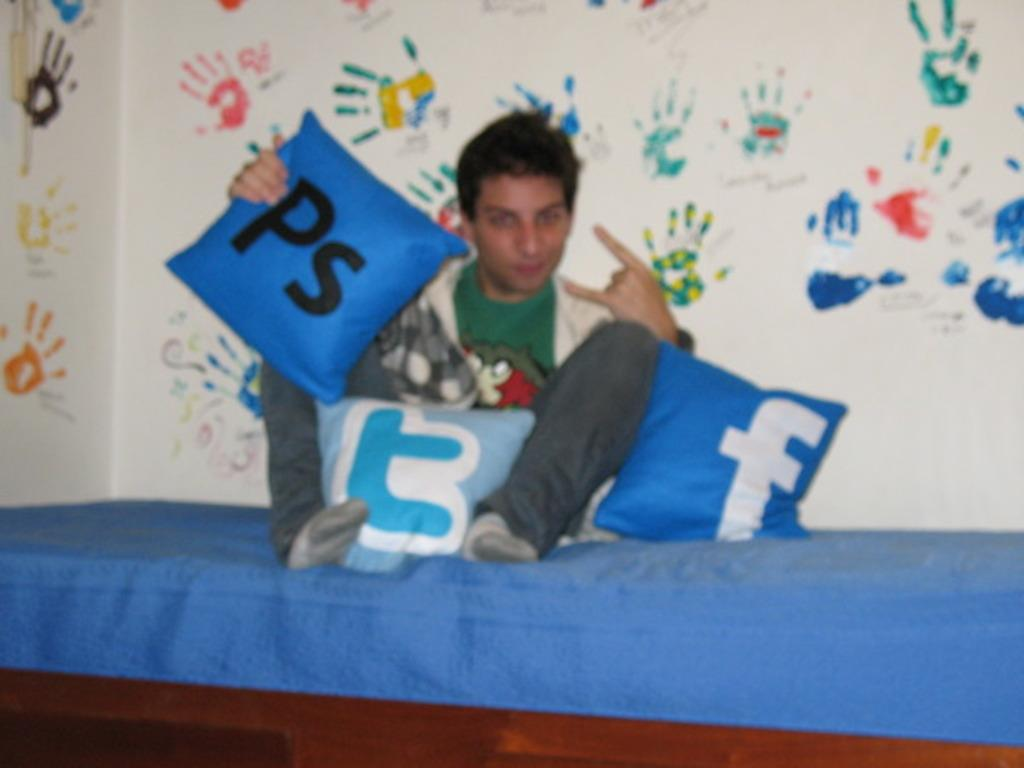<image>
Write a terse but informative summary of the picture. a boy on a bed holding a pillow that says 'ps' on it 